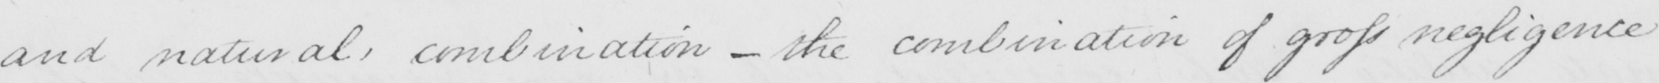What does this handwritten line say? and natural , combination  _  the combination of gross negligence 